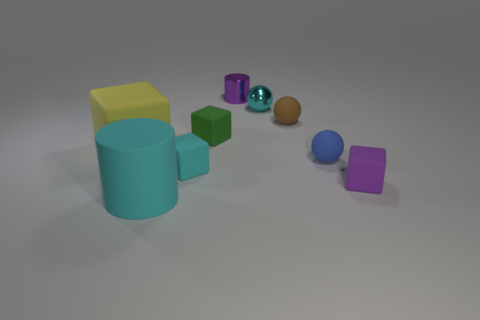Is the material of the tiny cyan cube the same as the cyan thing on the right side of the small metal cylinder?
Your answer should be very brief. No. Is the number of tiny cubes that are on the left side of the small purple shiny object greater than the number of yellow objects on the left side of the big yellow rubber block?
Offer a terse response. Yes. Are there any cyan matte objects that have the same size as the purple metal cylinder?
Keep it short and to the point. Yes. There is a metal thing in front of the tiny purple object behind the thing that is on the right side of the tiny blue ball; how big is it?
Make the answer very short. Small. The large matte block has what color?
Make the answer very short. Yellow. Is the number of shiny objects that are in front of the purple matte cube greater than the number of metallic cylinders?
Make the answer very short. No. There is a big cyan rubber cylinder; what number of matte blocks are left of it?
Your response must be concise. 1. What is the shape of the tiny shiny thing that is the same color as the rubber cylinder?
Provide a succinct answer. Sphere. Is there a big object that is behind the cylinder behind the small purple thing that is in front of the purple cylinder?
Provide a short and direct response. No. Do the purple matte block and the blue sphere have the same size?
Offer a terse response. Yes. 